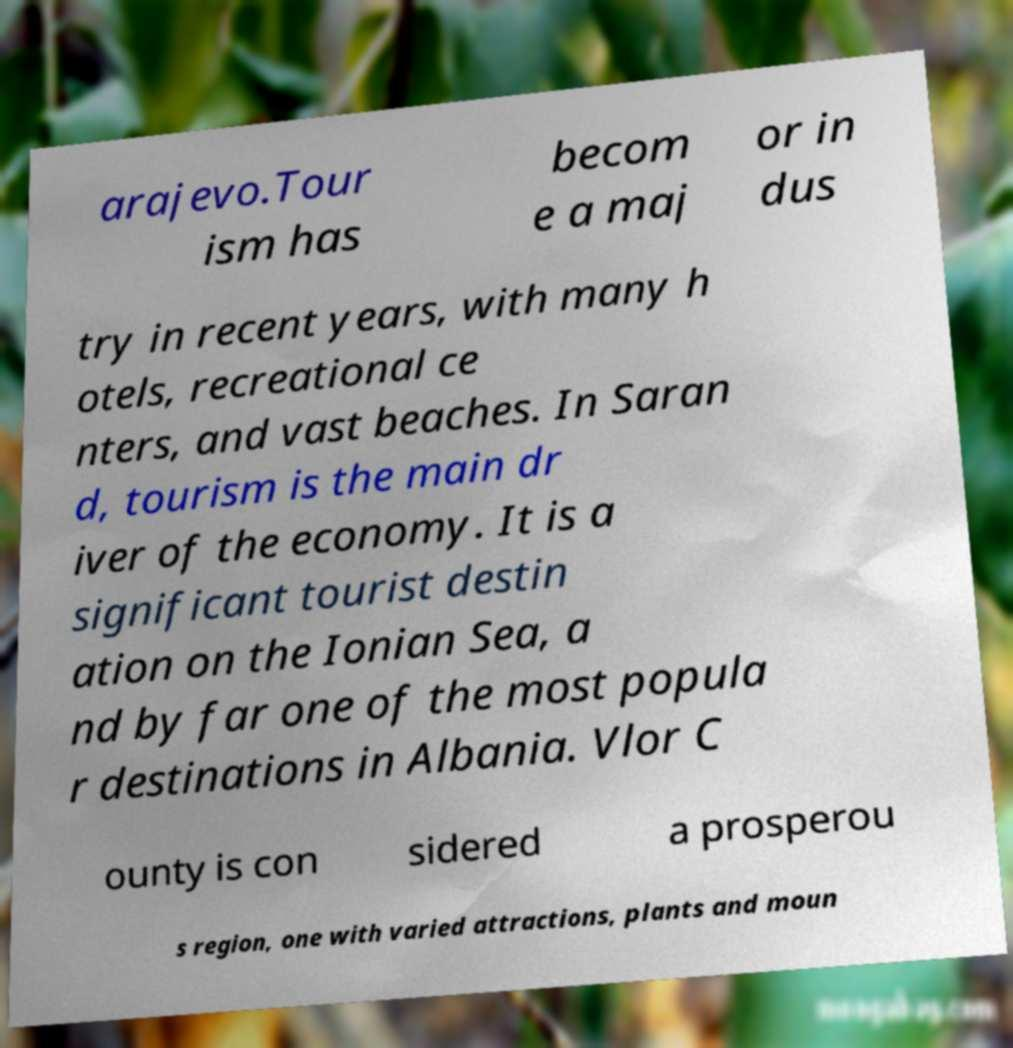Can you accurately transcribe the text from the provided image for me? arajevo.Tour ism has becom e a maj or in dus try in recent years, with many h otels, recreational ce nters, and vast beaches. In Saran d, tourism is the main dr iver of the economy. It is a significant tourist destin ation on the Ionian Sea, a nd by far one of the most popula r destinations in Albania. Vlor C ounty is con sidered a prosperou s region, one with varied attractions, plants and moun 